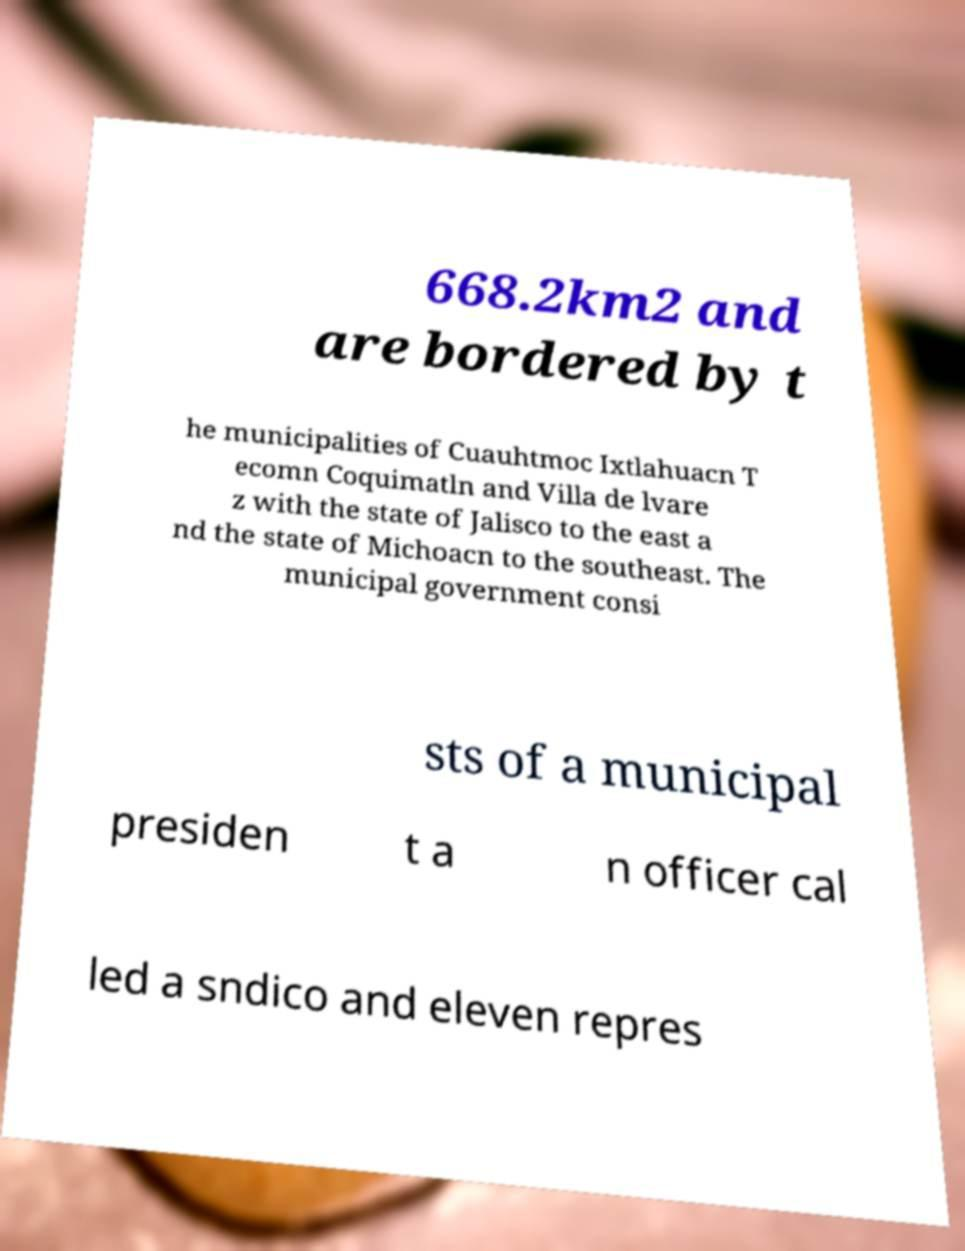I need the written content from this picture converted into text. Can you do that? 668.2km2 and are bordered by t he municipalities of Cuauhtmoc Ixtlahuacn T ecomn Coquimatln and Villa de lvare z with the state of Jalisco to the east a nd the state of Michoacn to the southeast. The municipal government consi sts of a municipal presiden t a n officer cal led a sndico and eleven repres 